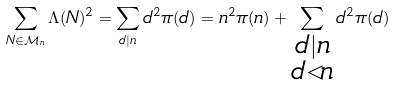<formula> <loc_0><loc_0><loc_500><loc_500>\sum _ { N \in \mathcal { M } _ { n } } \Lambda ( N ) ^ { 2 } = \sum _ { d | n } d ^ { 2 } \pi ( d ) = n ^ { 2 } \pi ( n ) + \sum _ { \substack { d | n \\ d < n } } d ^ { 2 } \pi ( d )</formula> 